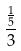Convert formula to latex. <formula><loc_0><loc_0><loc_500><loc_500>\frac { \frac { 1 } { 5 } } { 3 }</formula> 